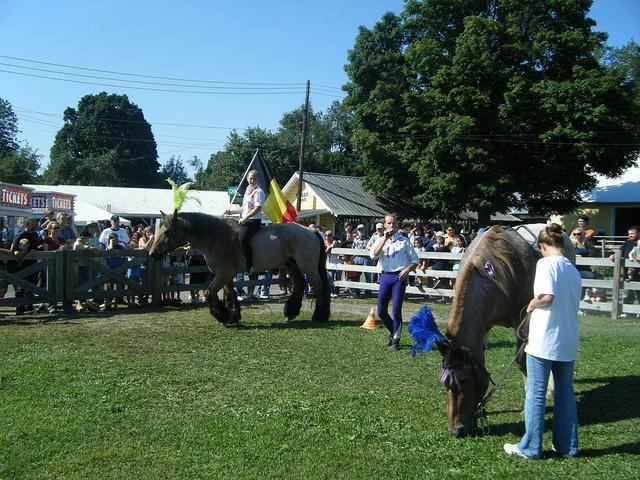How many horses are eating grass?
Give a very brief answer. 1. How many people are there?
Give a very brief answer. 4. How many horses can you see?
Give a very brief answer. 2. 